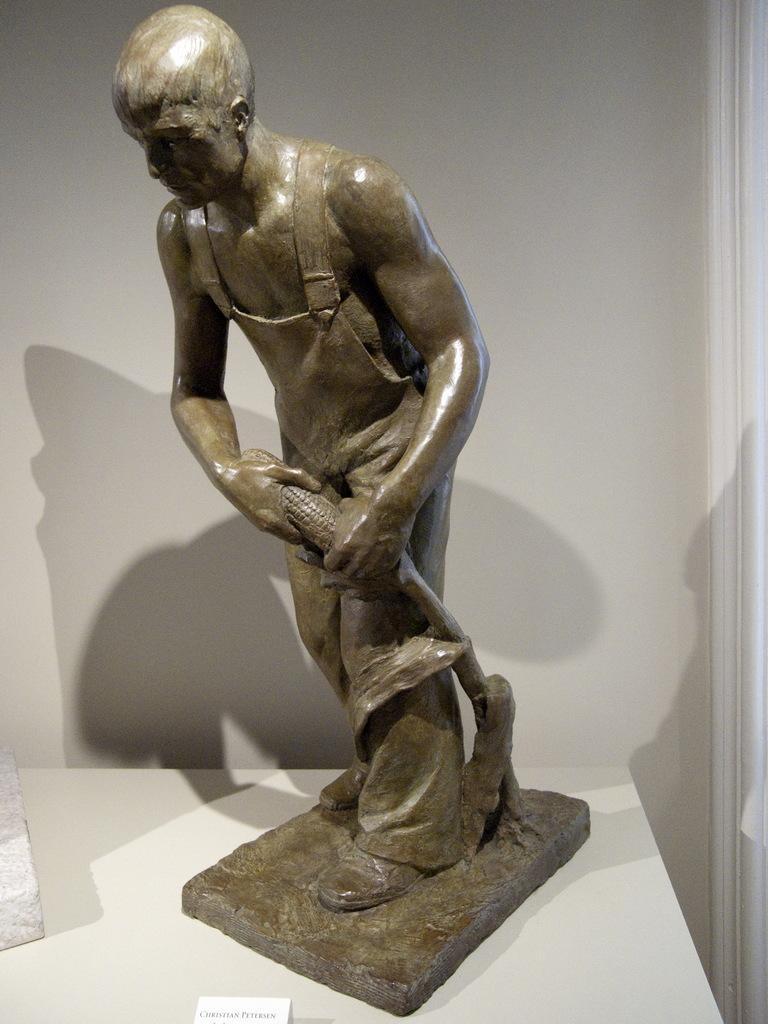Could you give a brief overview of what you see in this image? In this image we can see a statue on white surface. In front of the statue nameplate is there. Behind the statue white color wall is present. 